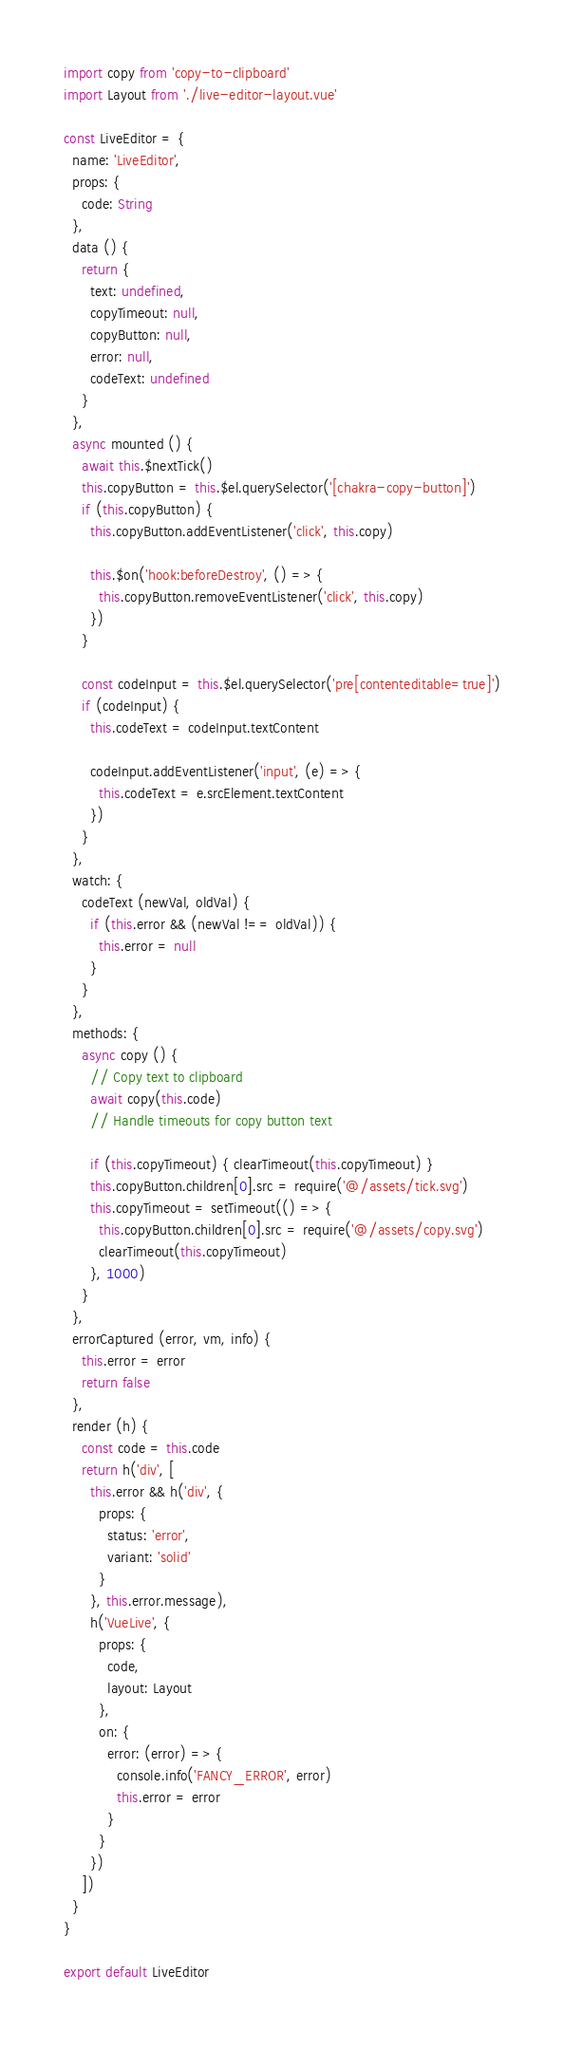<code> <loc_0><loc_0><loc_500><loc_500><_JavaScript_>import copy from 'copy-to-clipboard'
import Layout from './live-editor-layout.vue'

const LiveEditor = {
  name: 'LiveEditor',
  props: {
    code: String
  },
  data () {
    return {
      text: undefined,
      copyTimeout: null,
      copyButton: null,
      error: null,
      codeText: undefined
    }
  },
  async mounted () {
    await this.$nextTick()
    this.copyButton = this.$el.querySelector('[chakra-copy-button]')
    if (this.copyButton) {
      this.copyButton.addEventListener('click', this.copy)

      this.$on('hook:beforeDestroy', () => {
        this.copyButton.removeEventListener('click', this.copy)
      })
    }

    const codeInput = this.$el.querySelector('pre[contenteditable=true]')
    if (codeInput) {
      this.codeText = codeInput.textContent

      codeInput.addEventListener('input', (e) => {
        this.codeText = e.srcElement.textContent
      })
    }
  },
  watch: {
    codeText (newVal, oldVal) {
      if (this.error && (newVal !== oldVal)) {
        this.error = null
      }
    }
  },
  methods: {
    async copy () {
      // Copy text to clipboard
      await copy(this.code)
      // Handle timeouts for copy button text

      if (this.copyTimeout) { clearTimeout(this.copyTimeout) }
      this.copyButton.children[0].src = require('@/assets/tick.svg')
      this.copyTimeout = setTimeout(() => {
        this.copyButton.children[0].src = require('@/assets/copy.svg')
        clearTimeout(this.copyTimeout)
      }, 1000)
    }
  },
  errorCaptured (error, vm, info) {
    this.error = error
    return false
  },
  render (h) {
    const code = this.code
    return h('div', [
      this.error && h('div', {
        props: {
          status: 'error',
          variant: 'solid'
        }
      }, this.error.message),
      h('VueLive', {
        props: {
          code,
          layout: Layout
        },
        on: {
          error: (error) => {
            console.info('FANCY_ERROR', error)
            this.error = error
          }
        }
      })
    ])
  }
}

export default LiveEditor
</code> 